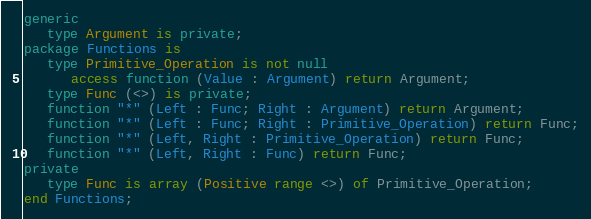<code> <loc_0><loc_0><loc_500><loc_500><_Ada_>generic
   type Argument is private;
package Functions is
   type Primitive_Operation is not null
      access function (Value : Argument) return Argument;
   type Func (<>) is private;
   function "*" (Left : Func; Right : Argument) return Argument;
   function "*" (Left : Func; Right : Primitive_Operation) return Func;
   function "*" (Left, Right : Primitive_Operation) return Func;
   function "*" (Left, Right : Func) return Func;
private
   type Func is array (Positive range <>) of Primitive_Operation;
end Functions;
</code> 